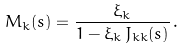<formula> <loc_0><loc_0><loc_500><loc_500>M _ { k } ( s ) = \frac { \xi _ { k } } { 1 - \xi _ { k } \, J _ { k k } ( s ) } \, .</formula> 